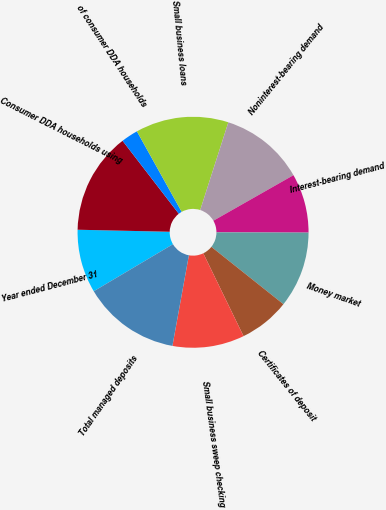Convert chart. <chart><loc_0><loc_0><loc_500><loc_500><pie_chart><fcel>Year ended December 31<fcel>Consumer DDA households using<fcel>of consumer DDA households<fcel>Small business loans<fcel>Noninterest-bearing demand<fcel>Interest-bearing demand<fcel>Money market<fcel>Certificates of deposit<fcel>Small business sweep checking<fcel>Total managed deposits<nl><fcel>8.88%<fcel>14.2%<fcel>2.37%<fcel>13.02%<fcel>11.83%<fcel>8.28%<fcel>10.65%<fcel>7.1%<fcel>10.06%<fcel>13.61%<nl></chart> 